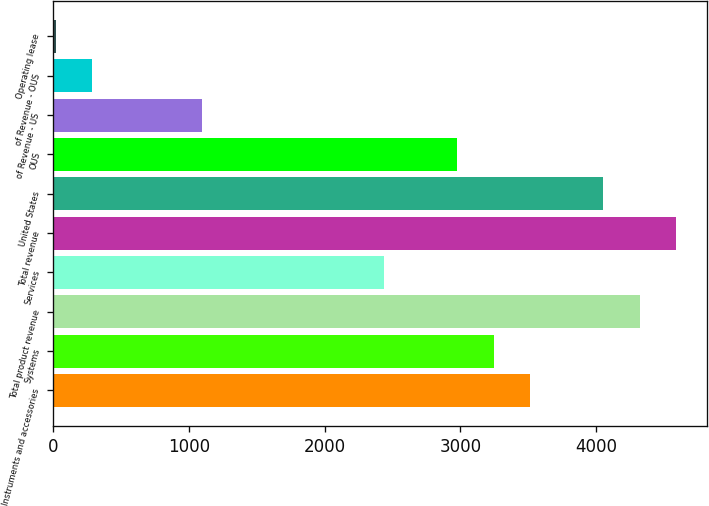<chart> <loc_0><loc_0><loc_500><loc_500><bar_chart><fcel>Instruments and accessories<fcel>Systems<fcel>Total product revenue<fcel>Services<fcel>Total revenue<fcel>United States<fcel>OUS<fcel>of Revenue - US<fcel>of Revenue - OUS<fcel>Operating lease<nl><fcel>3513.47<fcel>3244.48<fcel>4320.44<fcel>2437.51<fcel>4589.43<fcel>4051.45<fcel>2975.49<fcel>1092.56<fcel>285.59<fcel>16.6<nl></chart> 